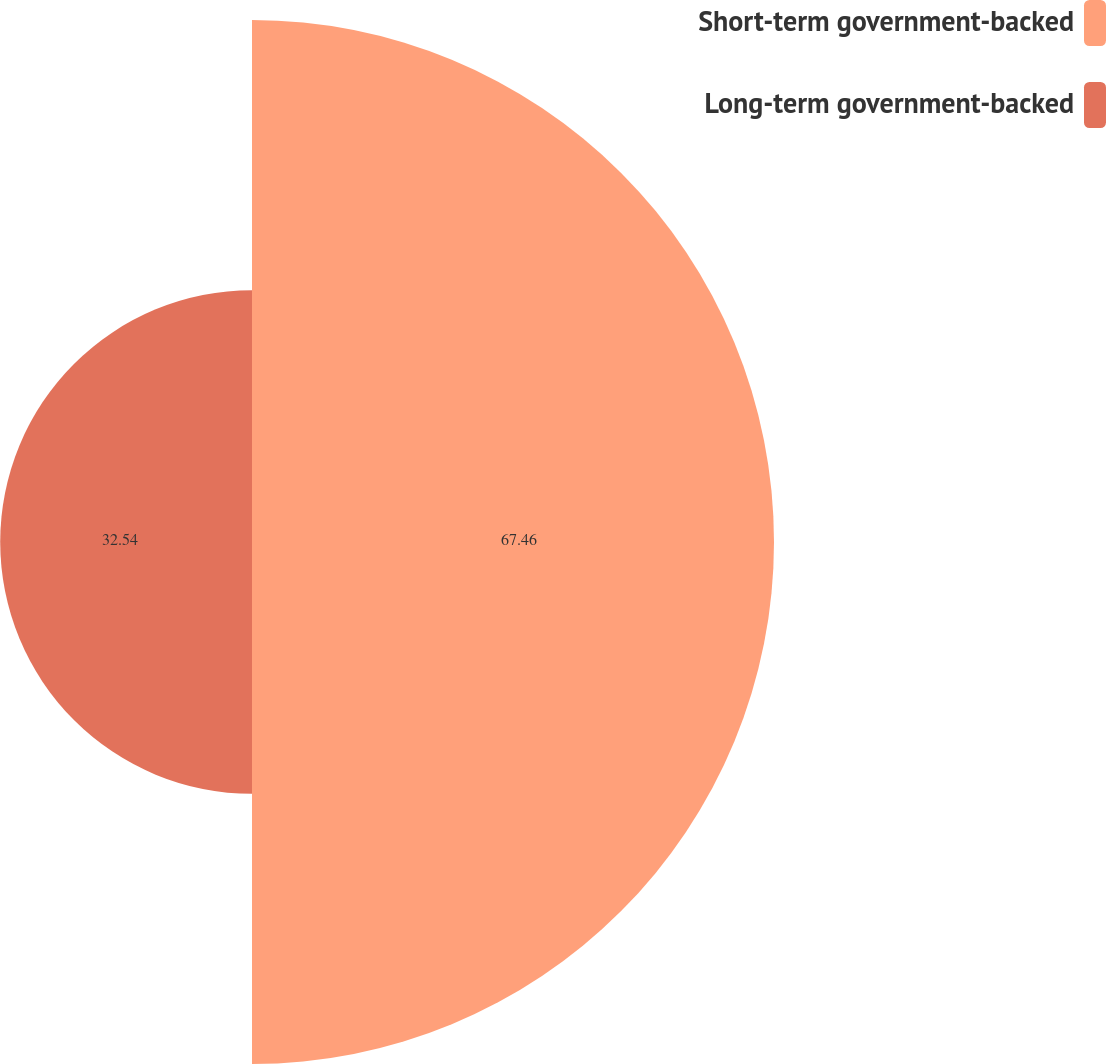<chart> <loc_0><loc_0><loc_500><loc_500><pie_chart><fcel>Short-term government-backed<fcel>Long-term government-backed<nl><fcel>67.46%<fcel>32.54%<nl></chart> 